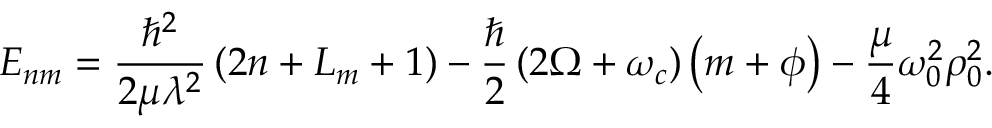Convert formula to latex. <formula><loc_0><loc_0><loc_500><loc_500>{ E } _ { n m } = \frac { \hbar { ^ } { 2 } } { 2 \mu \lambda ^ { 2 } } \left ( 2 n + L _ { m } + 1 \right ) - \frac { } { 2 } \left ( 2 \Omega + \omega _ { c } \right ) \left ( m + \phi \right ) - \frac { \mu } { 4 } \omega _ { 0 } ^ { 2 } \rho _ { 0 } ^ { 2 } .</formula> 